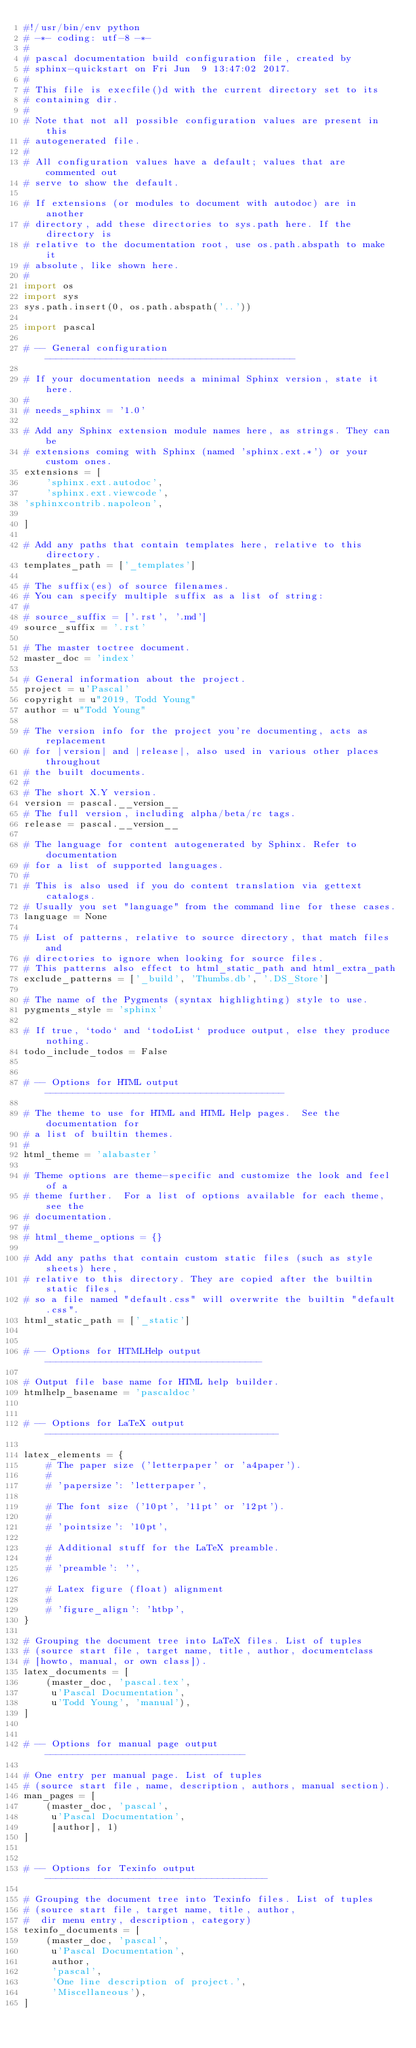Convert code to text. <code><loc_0><loc_0><loc_500><loc_500><_Python_>#!/usr/bin/env python
# -*- coding: utf-8 -*-
#
# pascal documentation build configuration file, created by
# sphinx-quickstart on Fri Jun  9 13:47:02 2017.
#
# This file is execfile()d with the current directory set to its
# containing dir.
#
# Note that not all possible configuration values are present in this
# autogenerated file.
#
# All configuration values have a default; values that are commented out
# serve to show the default.

# If extensions (or modules to document with autodoc) are in another
# directory, add these directories to sys.path here. If the directory is
# relative to the documentation root, use os.path.abspath to make it
# absolute, like shown here.
#
import os
import sys
sys.path.insert(0, os.path.abspath('..'))

import pascal

# -- General configuration ---------------------------------------------

# If your documentation needs a minimal Sphinx version, state it here.
#
# needs_sphinx = '1.0'

# Add any Sphinx extension module names here, as strings. They can be
# extensions coming with Sphinx (named 'sphinx.ext.*') or your custom ones.
extensions = [
    'sphinx.ext.autodoc',
    'sphinx.ext.viewcode',
'sphinxcontrib.napoleon',

]

# Add any paths that contain templates here, relative to this directory.
templates_path = ['_templates']

# The suffix(es) of source filenames.
# You can specify multiple suffix as a list of string:
#
# source_suffix = ['.rst', '.md']
source_suffix = '.rst'

# The master toctree document.
master_doc = 'index'

# General information about the project.
project = u'Pascal'
copyright = u"2019, Todd Young"
author = u"Todd Young"

# The version info for the project you're documenting, acts as replacement
# for |version| and |release|, also used in various other places throughout
# the built documents.
#
# The short X.Y version.
version = pascal.__version__
# The full version, including alpha/beta/rc tags.
release = pascal.__version__

# The language for content autogenerated by Sphinx. Refer to documentation
# for a list of supported languages.
#
# This is also used if you do content translation via gettext catalogs.
# Usually you set "language" from the command line for these cases.
language = None

# List of patterns, relative to source directory, that match files and
# directories to ignore when looking for source files.
# This patterns also effect to html_static_path and html_extra_path
exclude_patterns = ['_build', 'Thumbs.db', '.DS_Store']

# The name of the Pygments (syntax highlighting) style to use.
pygments_style = 'sphinx'

# If true, `todo` and `todoList` produce output, else they produce nothing.
todo_include_todos = False


# -- Options for HTML output -------------------------------------------

# The theme to use for HTML and HTML Help pages.  See the documentation for
# a list of builtin themes.
#
html_theme = 'alabaster'

# Theme options are theme-specific and customize the look and feel of a
# theme further.  For a list of options available for each theme, see the
# documentation.
#
# html_theme_options = {}

# Add any paths that contain custom static files (such as style sheets) here,
# relative to this directory. They are copied after the builtin static files,
# so a file named "default.css" will overwrite the builtin "default.css".
html_static_path = ['_static']


# -- Options for HTMLHelp output ---------------------------------------

# Output file base name for HTML help builder.
htmlhelp_basename = 'pascaldoc'


# -- Options for LaTeX output ------------------------------------------

latex_elements = {
    # The paper size ('letterpaper' or 'a4paper').
    #
    # 'papersize': 'letterpaper',

    # The font size ('10pt', '11pt' or '12pt').
    #
    # 'pointsize': '10pt',

    # Additional stuff for the LaTeX preamble.
    #
    # 'preamble': '',

    # Latex figure (float) alignment
    #
    # 'figure_align': 'htbp',
}

# Grouping the document tree into LaTeX files. List of tuples
# (source start file, target name, title, author, documentclass
# [howto, manual, or own class]).
latex_documents = [
    (master_doc, 'pascal.tex',
     u'Pascal Documentation',
     u'Todd Young', 'manual'),
]


# -- Options for manual page output ------------------------------------

# One entry per manual page. List of tuples
# (source start file, name, description, authors, manual section).
man_pages = [
    (master_doc, 'pascal',
     u'Pascal Documentation',
     [author], 1)
]


# -- Options for Texinfo output ----------------------------------------

# Grouping the document tree into Texinfo files. List of tuples
# (source start file, target name, title, author,
#  dir menu entry, description, category)
texinfo_documents = [
    (master_doc, 'pascal',
     u'Pascal Documentation',
     author,
     'pascal',
     'One line description of project.',
     'Miscellaneous'),
]



</code> 